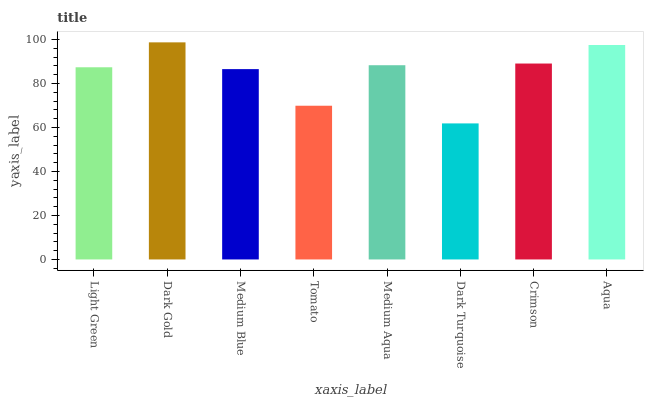Is Dark Turquoise the minimum?
Answer yes or no. Yes. Is Dark Gold the maximum?
Answer yes or no. Yes. Is Medium Blue the minimum?
Answer yes or no. No. Is Medium Blue the maximum?
Answer yes or no. No. Is Dark Gold greater than Medium Blue?
Answer yes or no. Yes. Is Medium Blue less than Dark Gold?
Answer yes or no. Yes. Is Medium Blue greater than Dark Gold?
Answer yes or no. No. Is Dark Gold less than Medium Blue?
Answer yes or no. No. Is Medium Aqua the high median?
Answer yes or no. Yes. Is Light Green the low median?
Answer yes or no. Yes. Is Tomato the high median?
Answer yes or no. No. Is Medium Blue the low median?
Answer yes or no. No. 